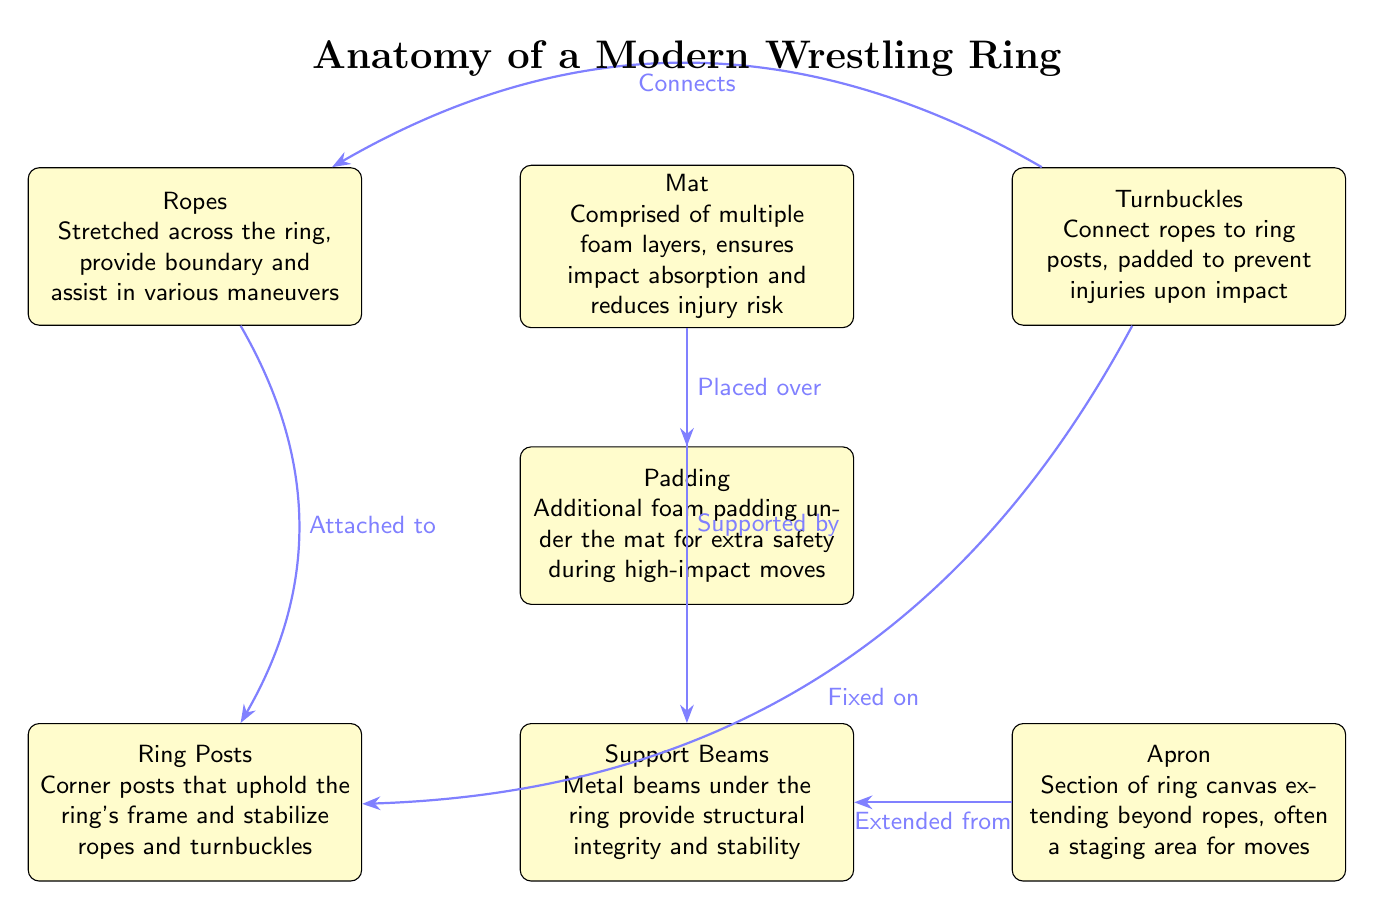What is the role of the mat? The mat is described as comprised of multiple foam layers that ensure impact absorption and reduce injury risk. This indicates its primary function is to provide a safe surface for wrestlers to perform on.
Answer: Impact absorption and reducing injury risk How many main components are highlighted in the diagram? The diagram features seven main components: mat, padding, ropes, turnbuckles, support beams, ring posts, and apron. Counting these components gives us the total number.
Answer: Seven What are the turnbuckles connected to? The turnbuckles are indicated to connect to the ropes and are also fixed on the ring posts, showcasing their role in stabilizing the ropes and maintaining the structure of the ring.
Answer: Ropes and ring posts What additional safety feature is mentioned under the mat? The diagram notes an additional foam padding under the mat, explicitly stating its purpose as extra safety during high-impact moves.
Answer: Additional foam padding How do the ropes assist in performance? The ropes are stretched across the ring and are stated to provide a boundary as well as assist in various maneuvers, demonstrating their utility in executing wrestling moves.
Answer: Provide boundary and assist in maneuvers What does the apron extend from? The diagram shows that the apron extends from the support beams, indicating the structural connection between these two components of the wrestling ring.
Answer: Support beams Which component provides structural integrity? The support beams are highlighted as the elements that provide structural integrity and stability beneath the ring, making them crucial for the ring's overall safety and durability.
Answer: Support beams Explain the connection between the ropes and the ring posts. The ropes are attached to the ring posts, and this attachment ensures that the ropes are securely held in place. This is vital for maintaining the boundaries of the ring and the wrestlers’ ability to use the ropes for various techniques.
Answer: Attached to ring posts What purpose does the padding serve? The padding is mentioned as additional foam padding under the mat, specifically for added safety during high-impact moves, making it a crucial safety feature in a wrestling ring.
Answer: Added safety during high-impact moves 